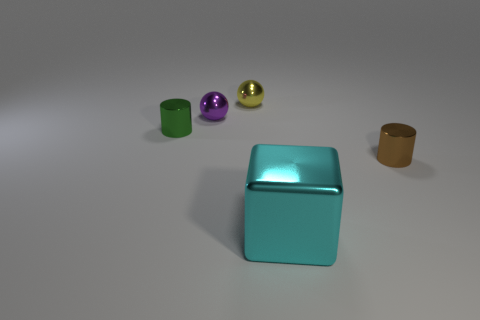Subtract all purple spheres. How many spheres are left? 1 Subtract 1 cylinders. How many cylinders are left? 1 Add 4 blue shiny balls. How many objects exist? 9 Subtract all blue cylinders. Subtract all red balls. How many cylinders are left? 2 Subtract all blue cubes. How many green cylinders are left? 1 Subtract all brown rubber cylinders. Subtract all brown objects. How many objects are left? 4 Add 2 spheres. How many spheres are left? 4 Add 1 tiny purple metal objects. How many tiny purple metal objects exist? 2 Subtract 0 green spheres. How many objects are left? 5 Subtract all cylinders. How many objects are left? 3 